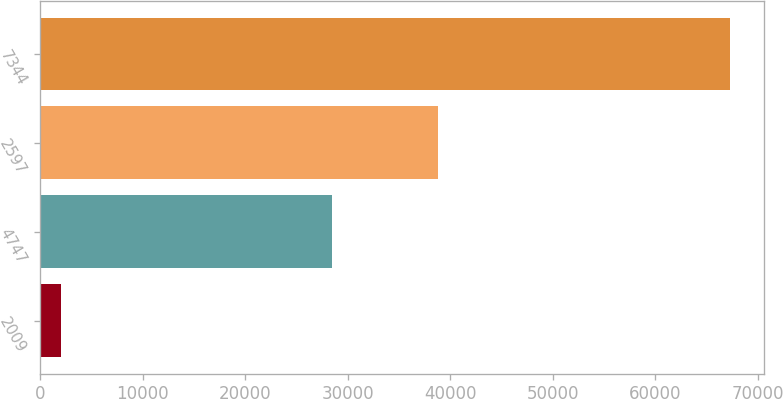Convert chart to OTSL. <chart><loc_0><loc_0><loc_500><loc_500><bar_chart><fcel>2009<fcel>4747<fcel>2597<fcel>7344<nl><fcel>2008<fcel>28473<fcel>38779<fcel>67252<nl></chart> 